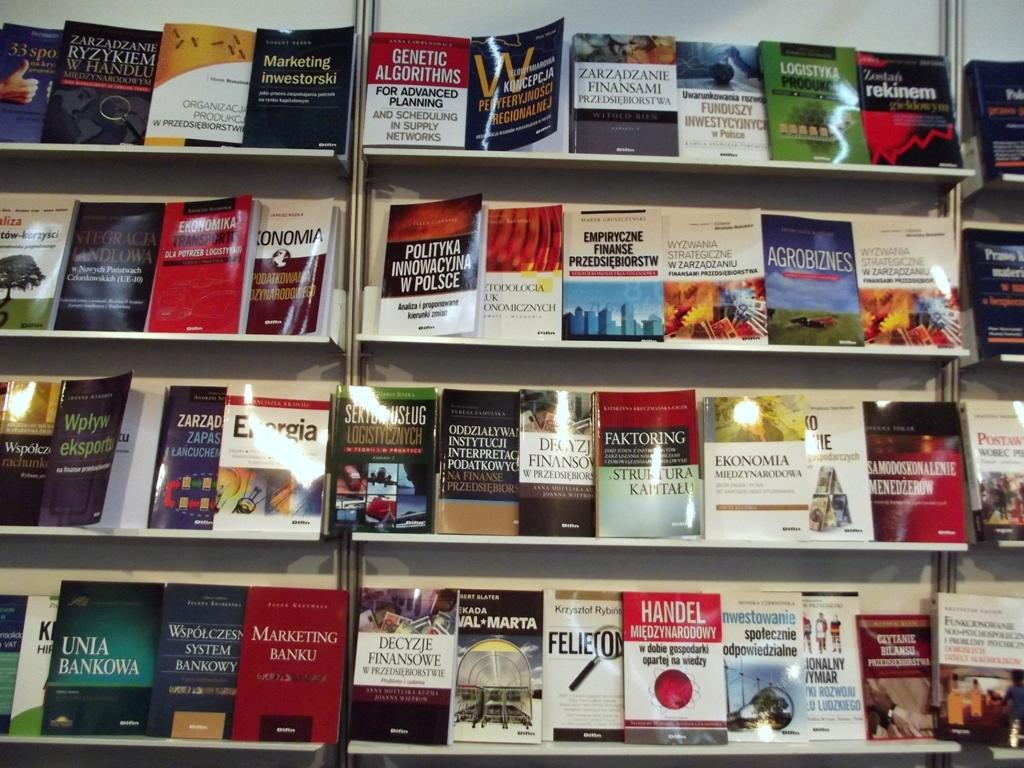What type of furniture is visible in the image? There is a cupboard with racks in the image. What is stored on the racks of the cupboard? There are many books on the racks. Can you describe the books on the racks? The books have writing on them. What type of quartz is used as a decoration on the books in the image? There is no quartz present in the image; the books have writing on them. 